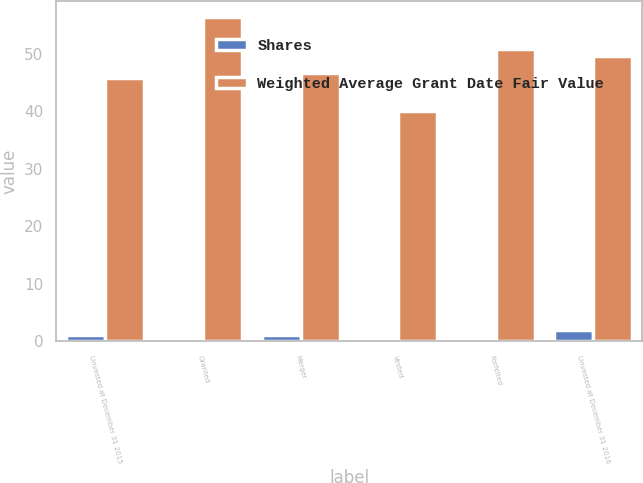<chart> <loc_0><loc_0><loc_500><loc_500><stacked_bar_chart><ecel><fcel>Unvested at December 31 2015<fcel>Granted<fcel>Merger<fcel>Vested<fcel>Forfeited<fcel>Unvested at December 31 2016<nl><fcel>Shares<fcel>1.1<fcel>0.4<fcel>1<fcel>0.5<fcel>0.1<fcel>1.9<nl><fcel>Weighted Average Grant Date Fair Value<fcel>45.82<fcel>56.4<fcel>46.64<fcel>40.06<fcel>50.77<fcel>49.55<nl></chart> 